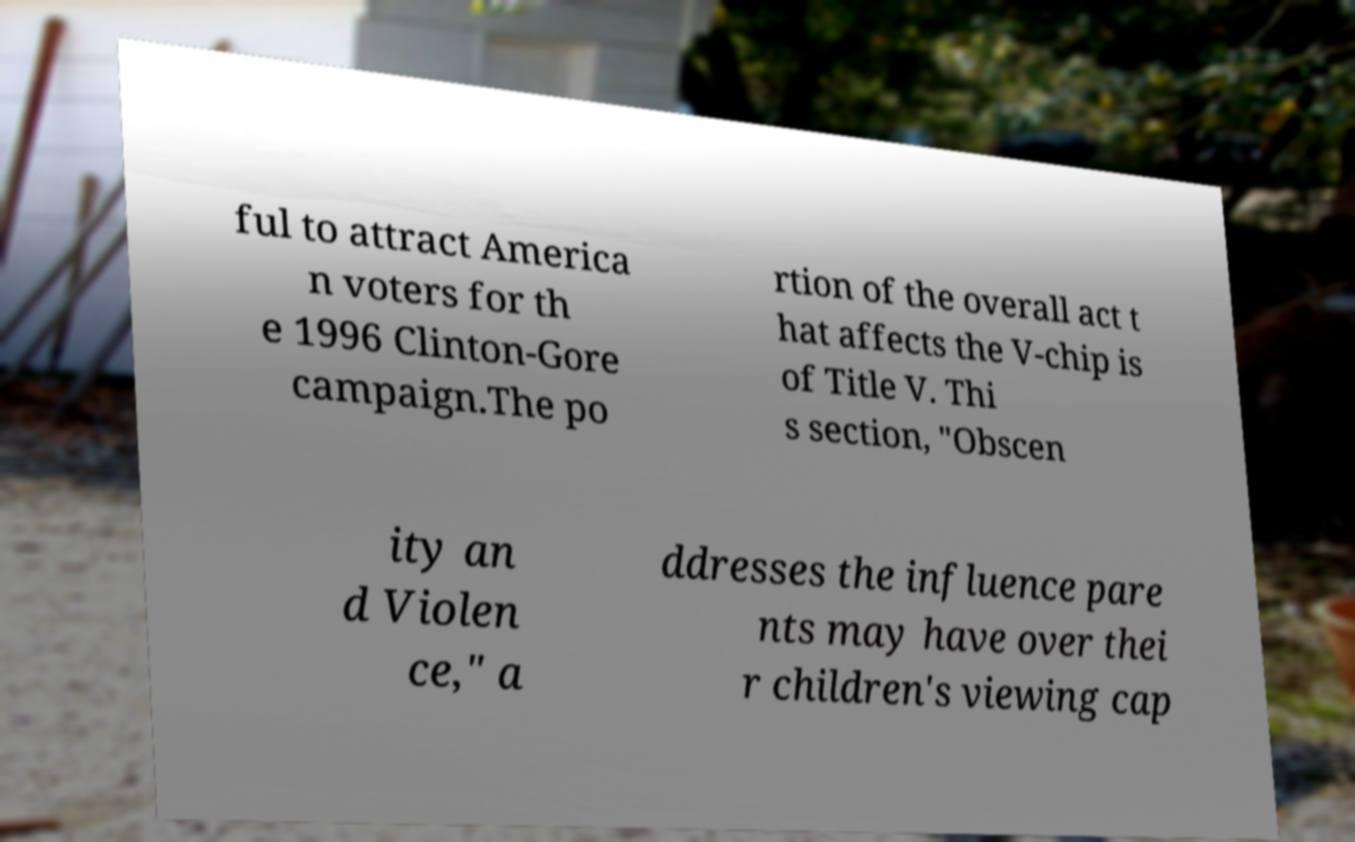Can you read and provide the text displayed in the image?This photo seems to have some interesting text. Can you extract and type it out for me? ful to attract America n voters for th e 1996 Clinton-Gore campaign.The po rtion of the overall act t hat affects the V-chip is of Title V. Thi s section, "Obscen ity an d Violen ce," a ddresses the influence pare nts may have over thei r children's viewing cap 